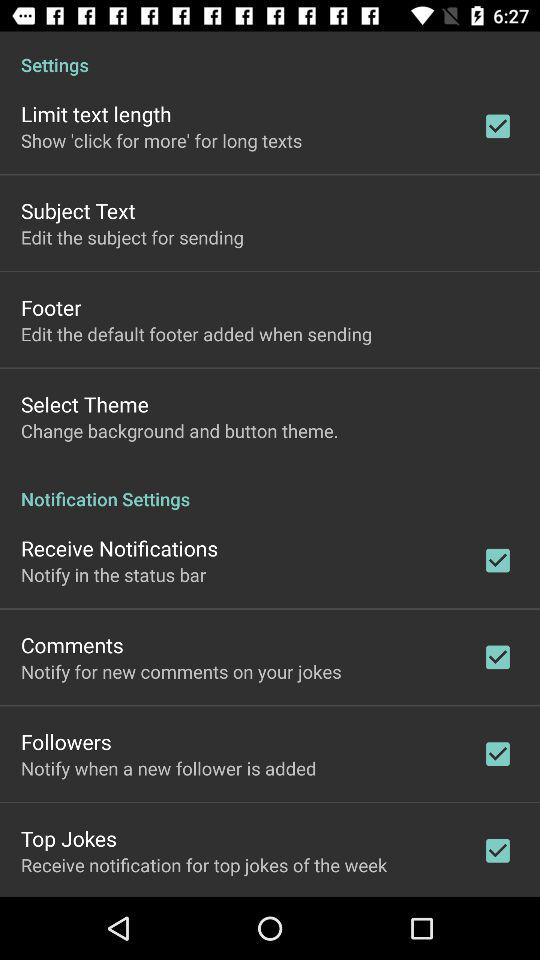What is the status of the "Receive Notifications" setting? The status is "on". 